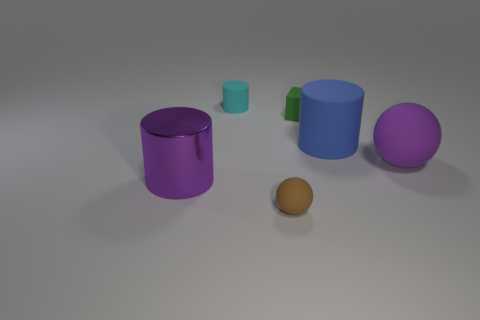There is another large thing that is the same shape as the big purple shiny object; what color is it? blue 